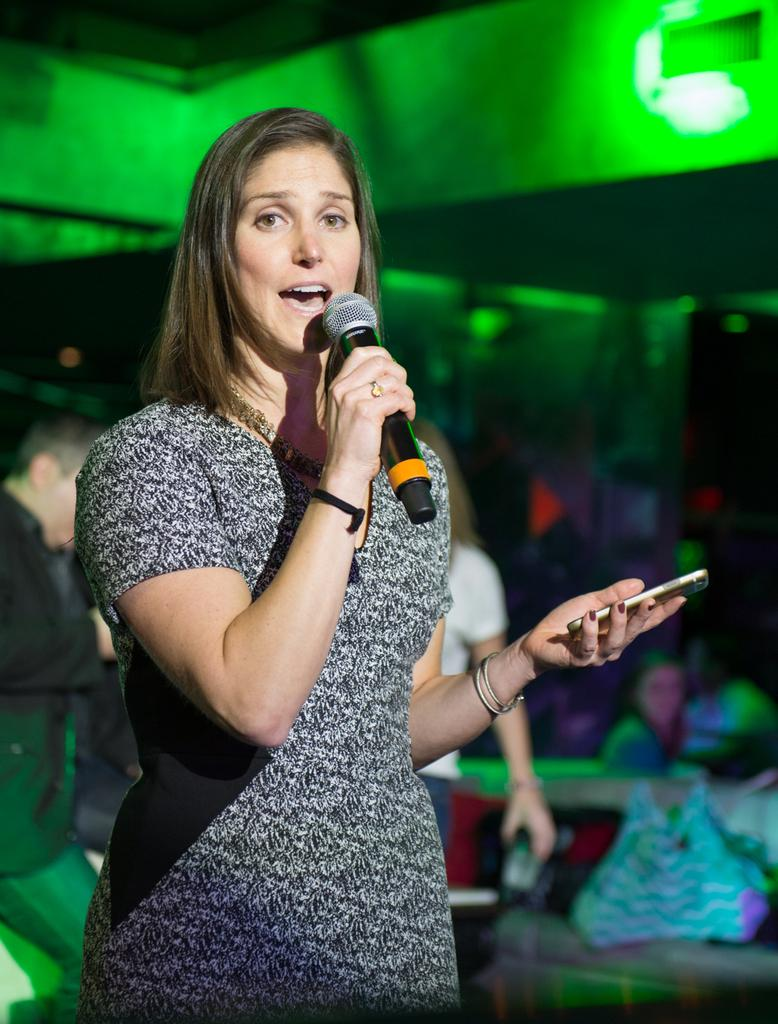Who is the main subject in the image? There is a woman in the image. What is the woman holding in her hands? The woman is holding a microphone and a phone. What can be seen in the background of the image? There is a wall and people in the background of the image. What type of news can be heard coming from the cow in the image? There is no cow present in the image, so it's not possible to determine what, if any, news might be heard. 